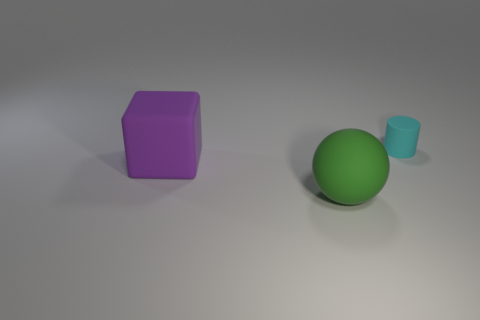Are there any other things that are the same shape as the purple object?
Ensure brevity in your answer.  No. Do the big green object and the large thing behind the green matte sphere have the same material?
Provide a succinct answer. Yes. There is a big matte thing to the right of the thing that is to the left of the matte object in front of the purple cube; what color is it?
Your response must be concise. Green. Are there any other things that are the same size as the cyan object?
Offer a very short reply. No. The large rubber ball is what color?
Give a very brief answer. Green. The rubber object that is in front of the large thing behind the large thing that is right of the matte cube is what shape?
Offer a terse response. Sphere. What number of other things are the same color as the large ball?
Your answer should be very brief. 0. Are there more rubber objects in front of the cyan rubber cylinder than big matte objects behind the rubber ball?
Give a very brief answer. Yes. Are there any large objects on the right side of the purple rubber cube?
Keep it short and to the point. Yes. Are there any purple cubes in front of the matte thing that is in front of the purple matte thing?
Keep it short and to the point. No. 